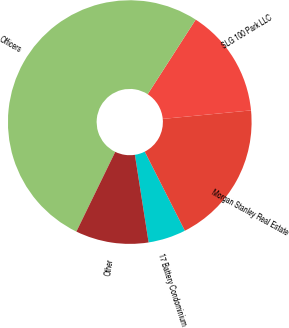<chart> <loc_0><loc_0><loc_500><loc_500><pie_chart><fcel>17 Battery Condominium<fcel>Morgan Stanley Real Estate<fcel>SLG 100 Park LLC<fcel>Officers<fcel>Other<nl><fcel>5.0%<fcel>19.06%<fcel>14.37%<fcel>51.88%<fcel>9.69%<nl></chart> 